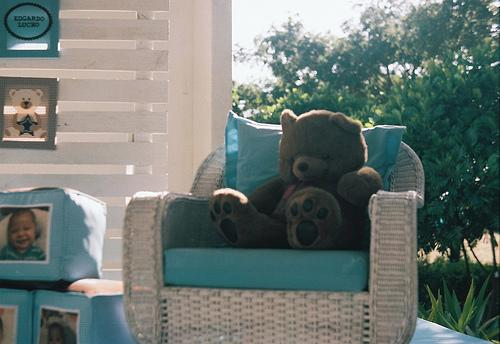What type of wall is present in the image, and what is hanging on it? A wood picket wall is present, with pictures and a blue sign hanging on it. How many items are on or near the white wicker chair, and what are they? Three items are on or near the chair: a teddy bear, blue cushions, and block pillows. Can you list three main colors of the objects in this image, including the chair? White, blue, and brown are the main colors of the objects in the image. Describe the type, color, and location of the pillows in the image. There are blue cushion pillows on the chair and blue-grey block pillows next to the chair. What kind of chair is there in the image and what is its color? There is a white wicker patio chair in the image. Is there any outdoor element visible in the scene? If so, describe it. Yes, there are trees with green leaves visible behind the bear. What object is seated on the chair, and what color is it? A brown teddy bear is sitting on the wicker chair. Count the number of objects in the image featuring the color blue. There are at least 8 blue objects, including cushions, pillows, a sign, and a frame. Can you provide a short sentiment analysis of the image? The image has a warm and cozy feel due to the combination of the teddy bear, the chair, and the pillows. What is the content of the picture on the pillow cube? The picture on the pillow cube shows a baby. Do the blue cushions appear to be inside or outside of the wicker chair? Inside Do you like the choice of pattern on the bright green curtains by the window? No, it's not mentioned in the image. Can you read the text on the blue sign on the wall? No, the text is not legible. Do the trees in the image have green leaves, or do they appear to be bare? Green leaves In reference to the chair's construction, describe the positioning of the right armrest. The right armrest of the wicker chair is located on the left side of the image, near the top of the chair. Which option best describes the stuffed animal on the chair: a) Green dinosaur, b) Brown teddy bear, c) Yellow duck? b) Brown teddy bear Is there any evidence of a gathering or celebration taking place in the image? No, there is no evidence of a gathering or celebration. Write a haiku about the wicker chair scene. White wicker chair sits, What is the name written on the blue frame in the image? Cannot determine the name due to the low resolution. Create a short story that involves the teddy bear and the blue pillow. Once upon a time in a cozy corner, a brown teddy bear found comfort on a white wicker chair with blue cushions. As the sun lit the room, the bear met a new friend: a blue pillow that listened to its dreams and whispered secrets of the softest sleep. What kind of plant is visible in the image? Is it pointy and green, or round and red? Pointy and green What is the color of the wicker chair in the image? White Describe the blue cushions on the chair in terms of their placement and size. The blue cushions are placed inside the wicker chair, and they are large enough to cover most of the seat. Describe the scene involving the teddy bear, chair, and cushions with an emphasis on their colors. A brown teddy bear is sitting on a white wicker chair with blue cushions inside. Provide a detailed description of the picture hanging on the wall featuring the animated bear. The picture displays an animated bear holding a star, it is in a colorful frame, and it is hanging on the wood picket wall. Write a poetic description of the image focusing on the elements of nature present. Amidst verdant trees and sunlit pillows, a plush bear finds repose on a white wicker throne with cushions of azure hue. Identify which object is by the porch: a plant or a lamp. A plant 